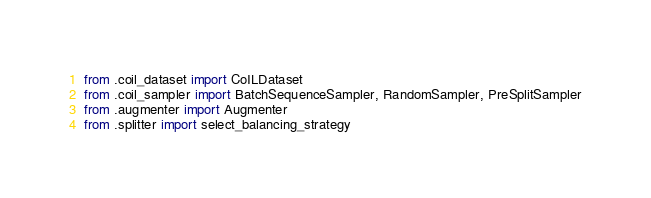<code> <loc_0><loc_0><loc_500><loc_500><_Python_>from .coil_dataset import CoILDataset
from .coil_sampler import BatchSequenceSampler, RandomSampler, PreSplitSampler
from .augmenter import Augmenter
from .splitter import select_balancing_strategy</code> 